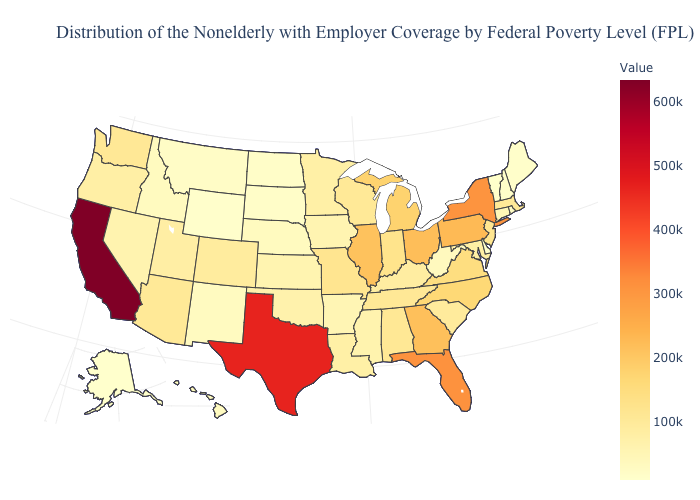Among the states that border Minnesota , does North Dakota have the lowest value?
Keep it brief. Yes. Among the states that border South Dakota , does North Dakota have the highest value?
Answer briefly. No. Among the states that border Wisconsin , which have the highest value?
Keep it brief. Illinois. Does the map have missing data?
Concise answer only. No. Which states have the lowest value in the Northeast?
Give a very brief answer. Vermont. Does California have the lowest value in the West?
Answer briefly. No. Is the legend a continuous bar?
Concise answer only. Yes. 